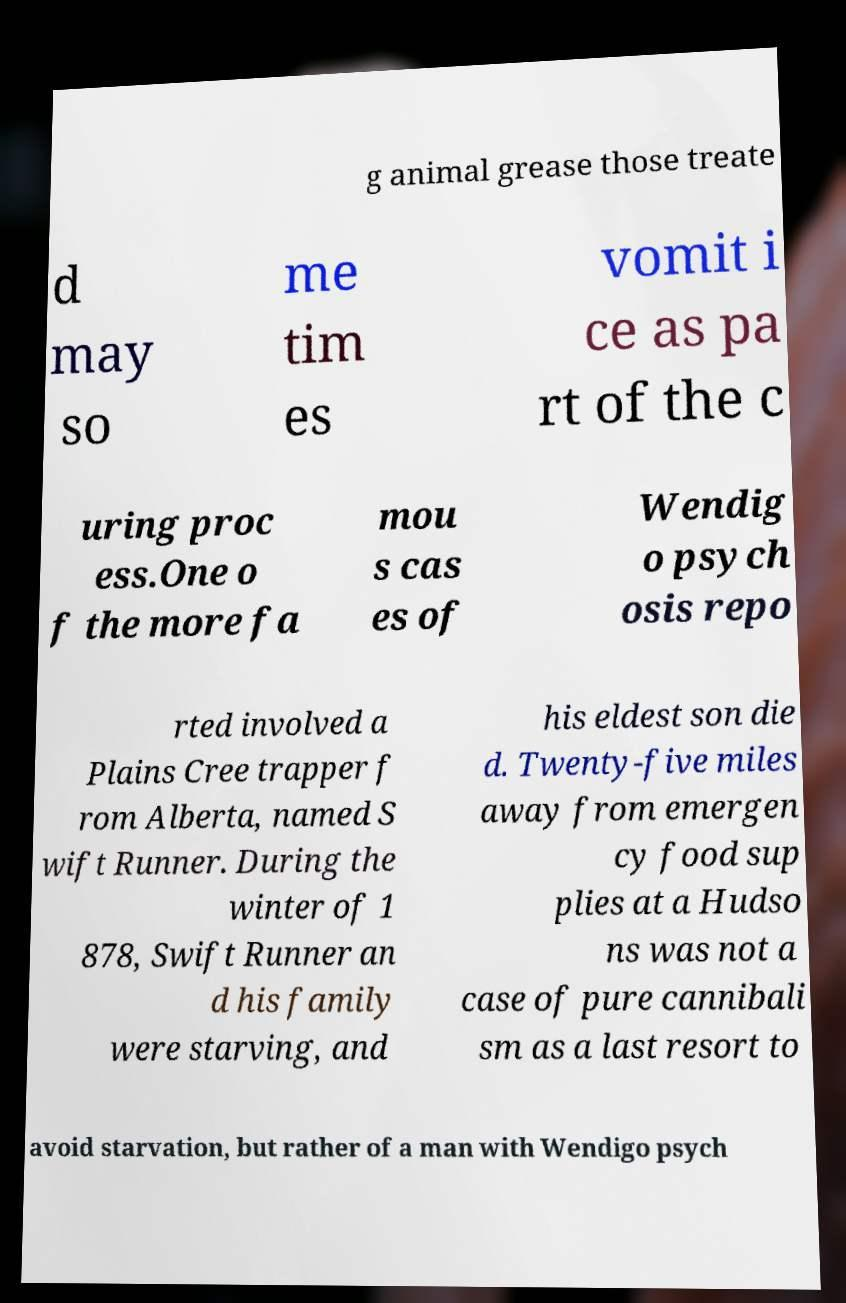What messages or text are displayed in this image? I need them in a readable, typed format. g animal grease those treate d may so me tim es vomit i ce as pa rt of the c uring proc ess.One o f the more fa mou s cas es of Wendig o psych osis repo rted involved a Plains Cree trapper f rom Alberta, named S wift Runner. During the winter of 1 878, Swift Runner an d his family were starving, and his eldest son die d. Twenty-five miles away from emergen cy food sup plies at a Hudso ns was not a case of pure cannibali sm as a last resort to avoid starvation, but rather of a man with Wendigo psych 